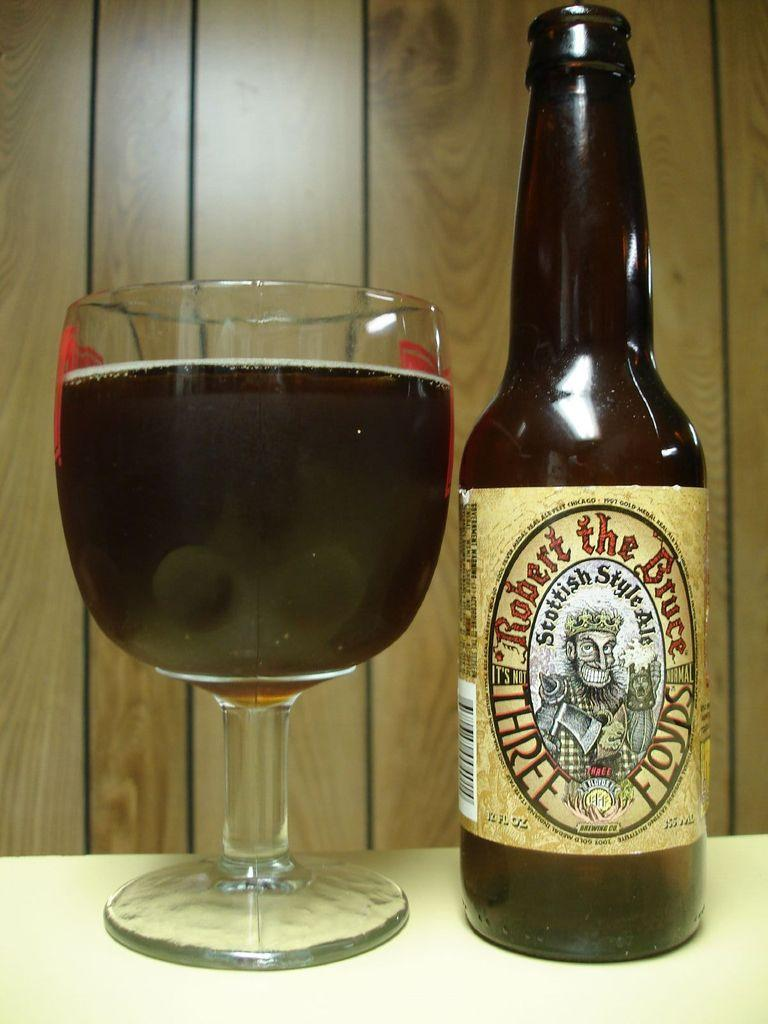<image>
Write a terse but informative summary of the picture. a bottle of robert the bruce three floyds standing next to a glass full of it 